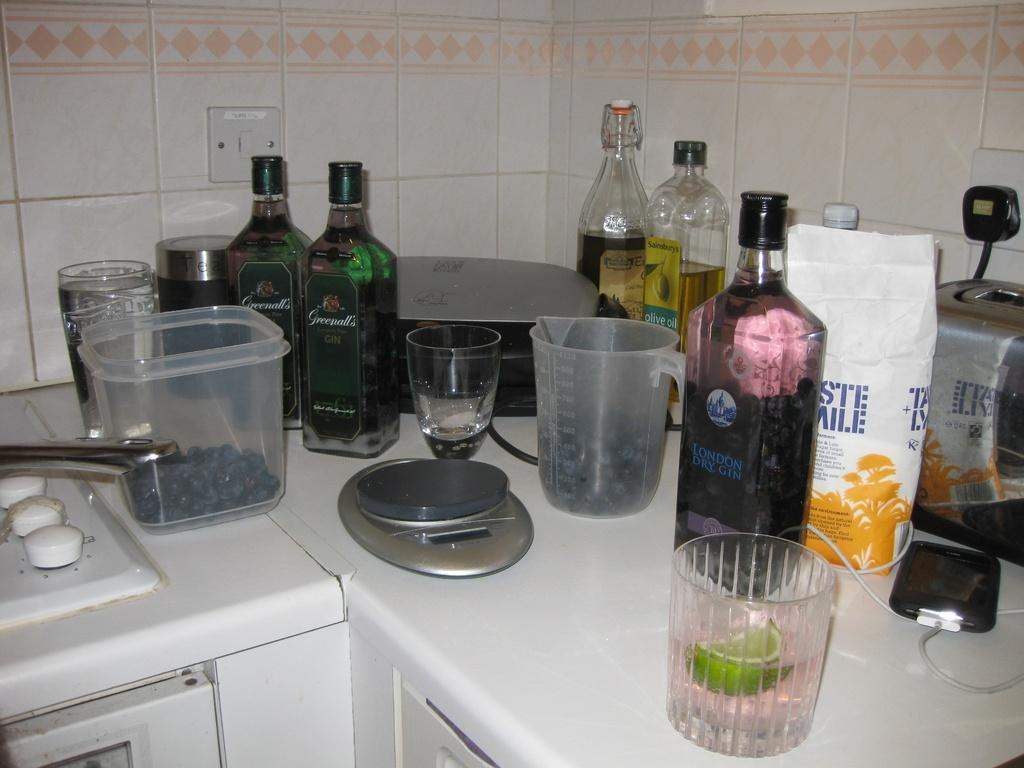What is the setting of the image? The image is of the inside of a location. What objects can be seen in the foreground of the image? There are glasses, jars, and bottles in the foreground of the image. How are these objects arranged in the image? These items are placed on a platform. What can be seen in the background of the image? There is a switch board and a wall in the background of the image. Is there a woman holding a bead in the image? There is no woman or bead present in the image. How many rats can be seen interacting with the switch board in the image? There are no rats present in the image; the switch board is not interacting with any animals. 